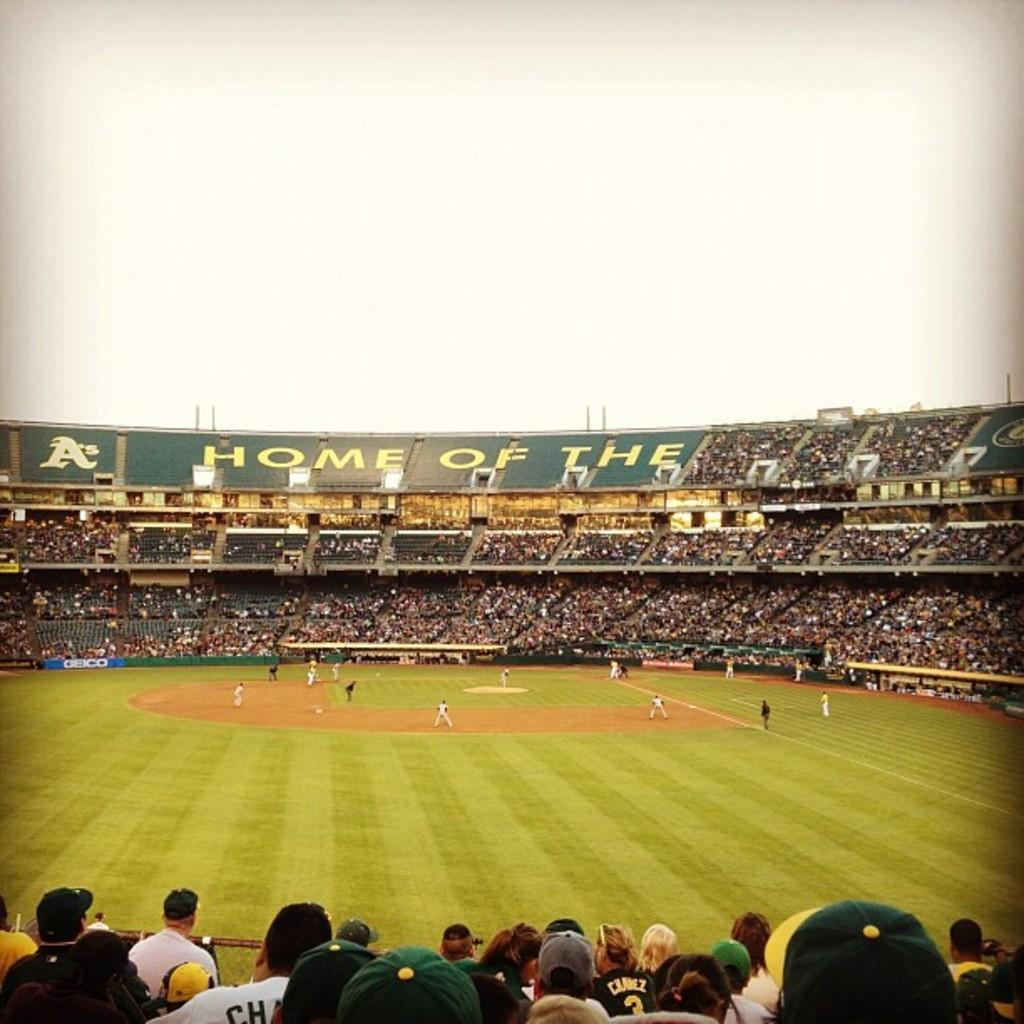<image>
Share a concise interpretation of the image provided. A stadium contains the word HOME on one of its walls. 